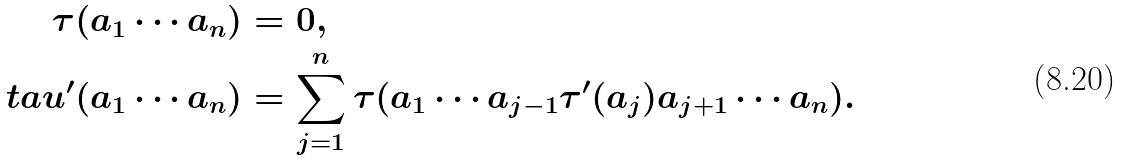Convert formula to latex. <formula><loc_0><loc_0><loc_500><loc_500>\tau ( a _ { 1 } \cdots a _ { n } ) & = 0 , \\ \quad t a u ^ { \prime } ( a _ { 1 } \cdots a _ { n } ) & = \sum _ { j = 1 } ^ { n } \tau ( a _ { 1 } \cdots a _ { j - 1 } \tau ^ { \prime } ( a _ { j } ) a _ { j + 1 } \cdots a _ { n } ) .</formula> 